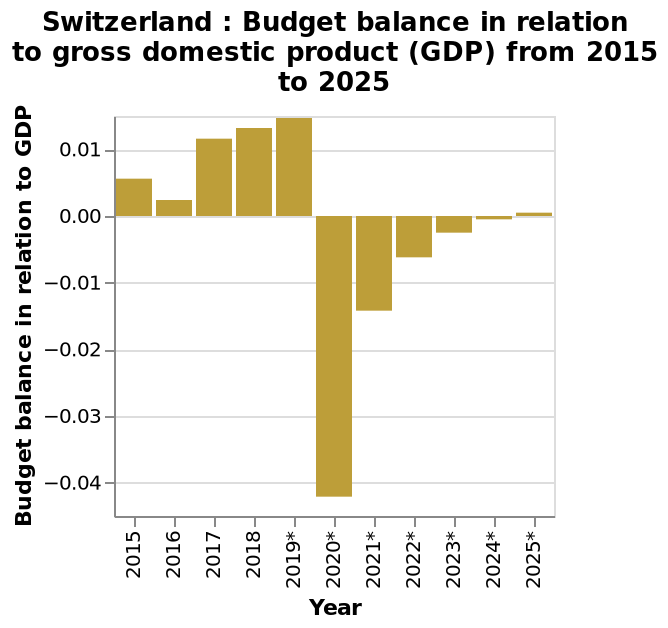<image>
What does the x-axis represent? The x-axis represents the years from 2015 to 2025 along a categorical scale. What does the y-axis measure? The y-axis measures the Budget balance in relation to GDP as a categorical scale ranging from -0.04 to 0.01. Is the budget currently in a better position compared to its state after the 2020 incident? Yes, although the budget has recovered to some extent, it is still not at the level it was before the 2020 incident. Did the budget fully recover after the 2020 incident? No, the budget has not fully recovered and is still not at its previous level. 